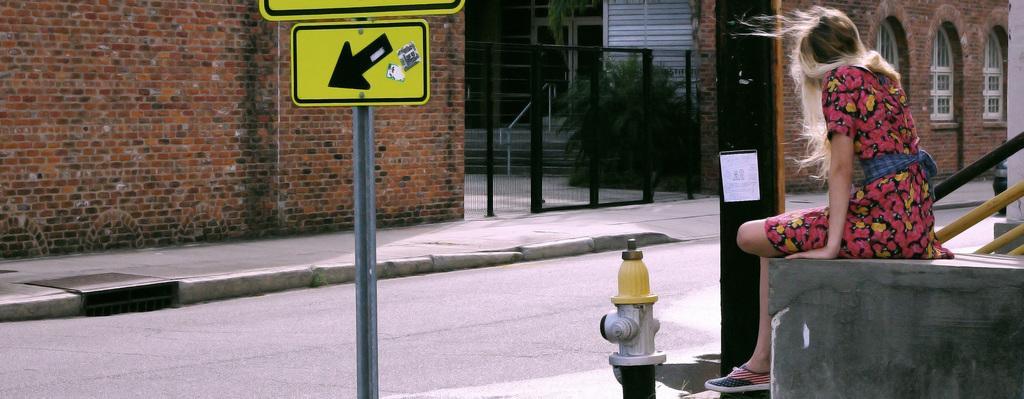Can you describe this image briefly? In this image on the right side there is one woman who is sitting beside her there are some stairs, and in the background there are some houses, plants and gate. In the foreground there are some poles boards and one fire extinguisher, at the bottom there is a road. 